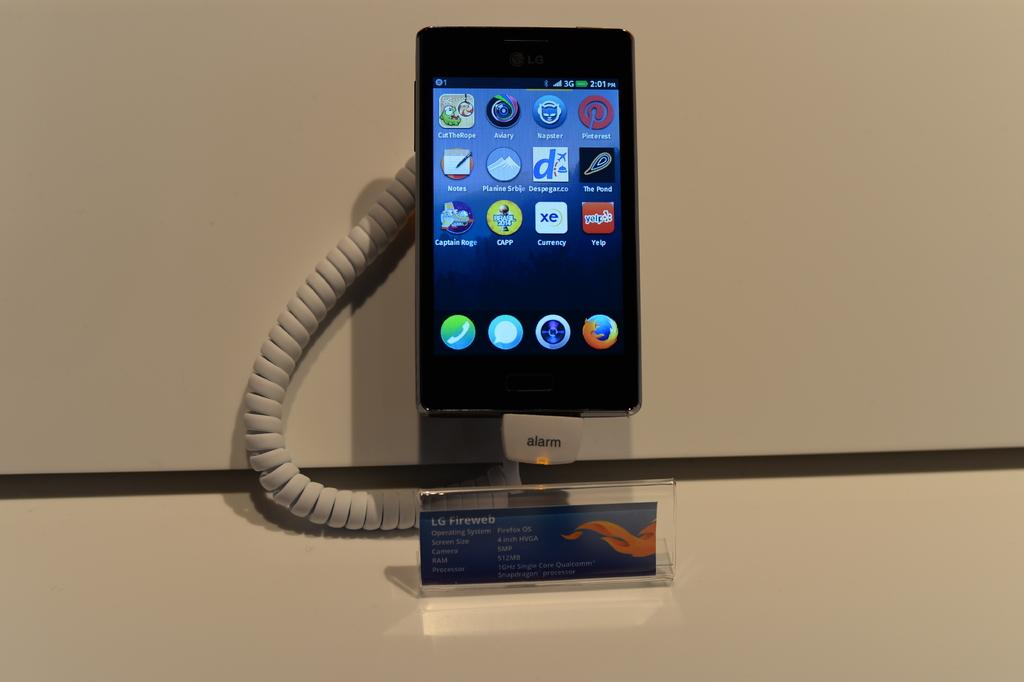<image>
Create a compact narrative representing the image presented. display model of a lg fireweb phone that is attached to an alarm 